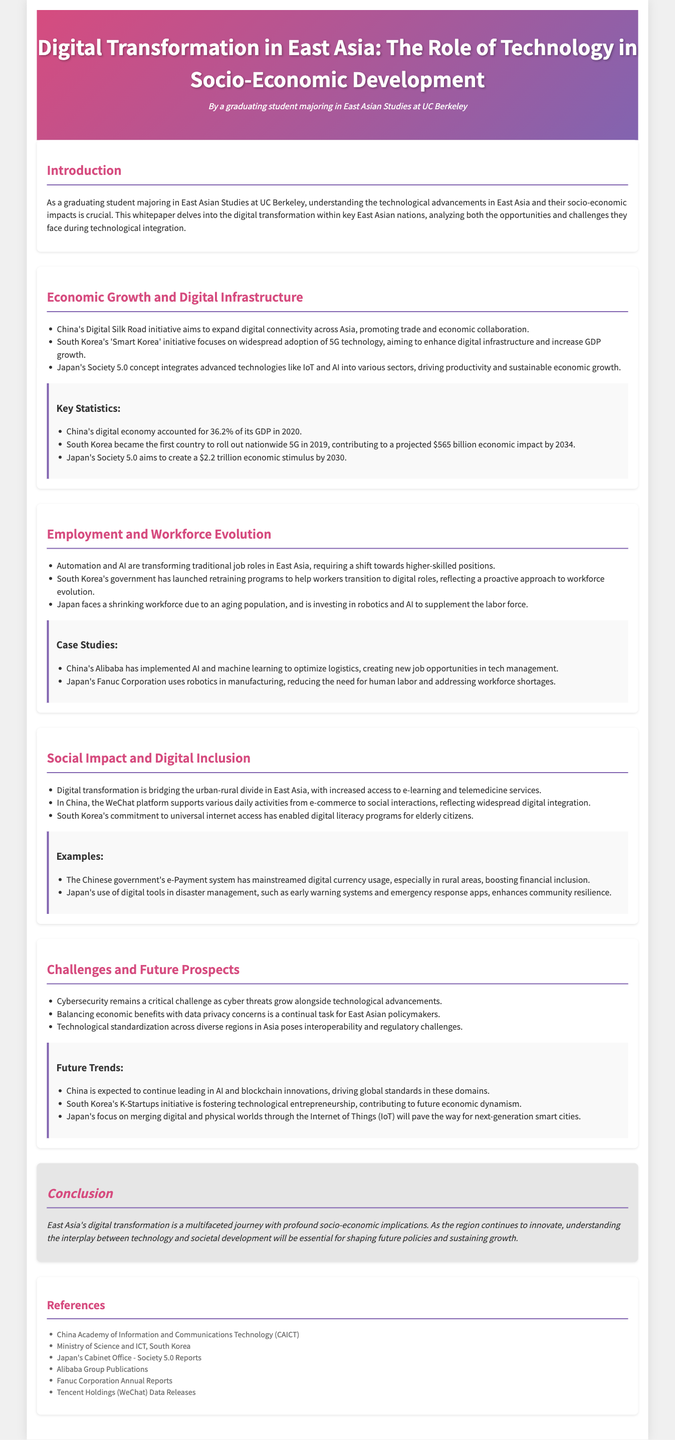What is the title of the whitepaper? The title of the whitepaper is stated in the header section, summarizing its focus on technology and socio-economic development in East Asia.
Answer: Digital Transformation in East Asia: The Role of Technology in Socio-Economic Development What is the projected economic impact of South Korea's 5G rollout by 2034? This information is found in the "Economic Growth and Digital Infrastructure" section, highlighting the expected financial benefits of the initiative.
Answer: $565 billion What concept integrates IoT and AI in Japan? The "Economic Growth and Digital Infrastructure" section includes this concept as a part of Japan's strategy for advancing socio-economic growth.
Answer: Society 5.0 What percentage of China's GDP did its digital economy account for in 2020? The statistics provided in the document indicate the share of the digital economy in China's overall economy for that year.
Answer: 36.2% What challenge does the document mention related to cybersecurity? The "Challenges and Future Prospects" section highlights this issue as a significant concern amidst digital transformation.
Answer: Critical challenge What initiative in South Korea focuses on digital literacy for elderly citizens? The document mentions this initiative as part of South Korea's efforts to support social inclusion through technology.
Answer: Universal internet access Which company uses robotics in manufacturing in Japan? The case studies section lists this company as a prime example of robotics in the workforce to address labor shortages.
Answer: Fanuc Corporation What program has South Korea launched to aid workers? This information appears under the "Employment and Workforce Evolution" section, indicating proactive government measures.
Answer: Retraining programs 